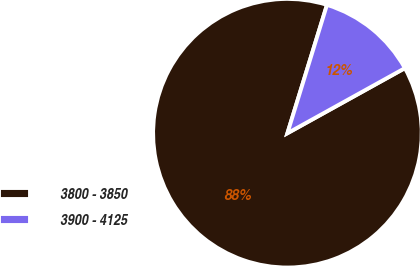Convert chart. <chart><loc_0><loc_0><loc_500><loc_500><pie_chart><fcel>3800 - 3850<fcel>3900 - 4125<nl><fcel>87.81%<fcel>12.19%<nl></chart> 